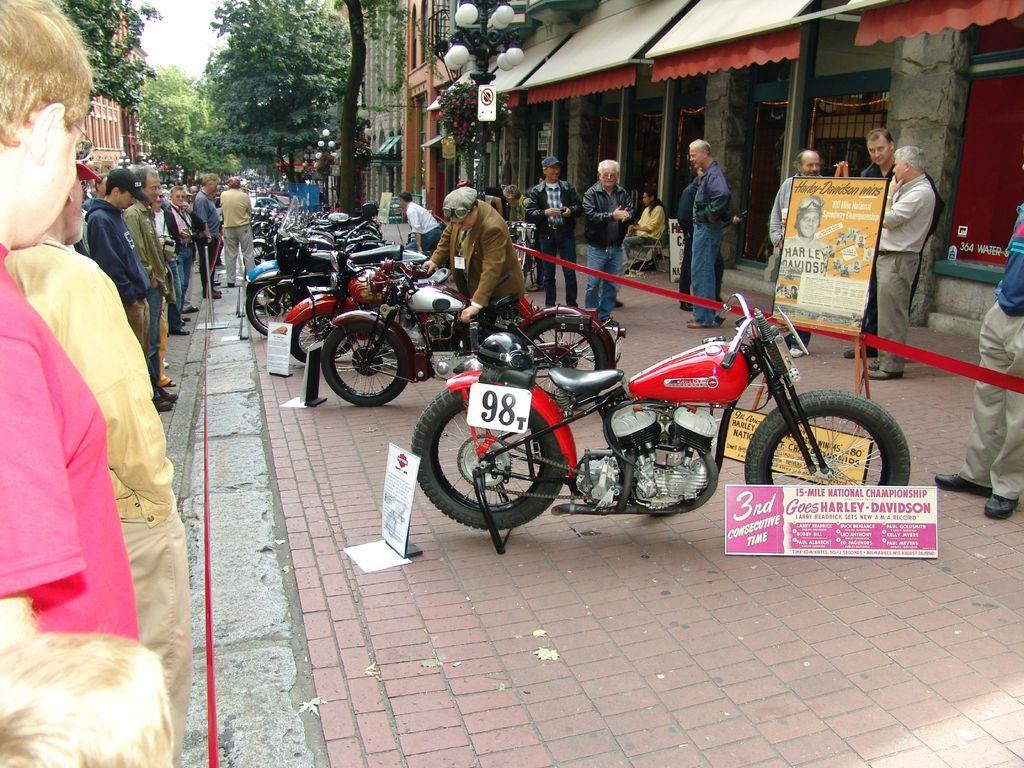What can be seen in the image? There are people standing and bikes in the image. What is visible in the background of the image? In the background, there are boards, shops, buildings, lights, and trees. How many types of structures can be seen in the background? There are three types of structures visible in the background: boards, shops, and buildings. What type of machine is being used to care for the trees in the image? There is no machine visible in the image, and the trees do not appear to be receiving any care. 